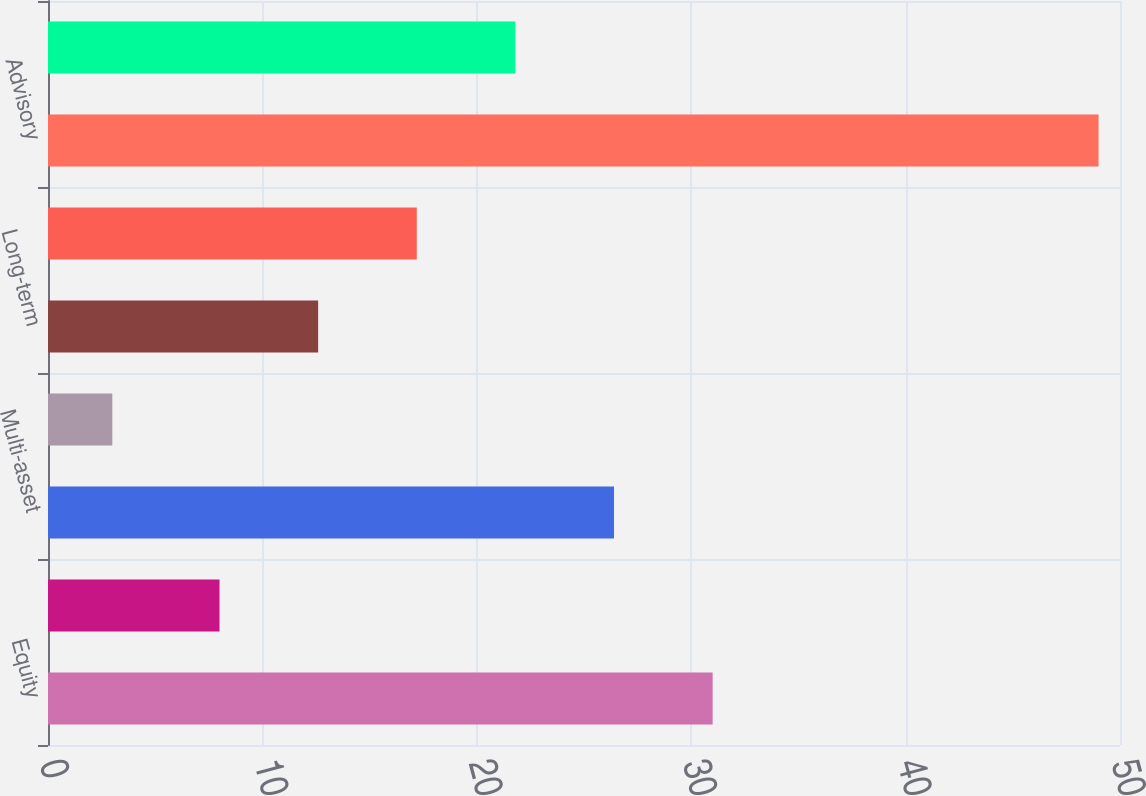Convert chart to OTSL. <chart><loc_0><loc_0><loc_500><loc_500><bar_chart><fcel>Equity<fcel>Fixed income<fcel>Multi-asset<fcel>Alternatives<fcel>Long-term<fcel>Cash management<fcel>Advisory<fcel>Total<nl><fcel>31<fcel>8<fcel>26.4<fcel>3<fcel>12.6<fcel>17.2<fcel>49<fcel>21.8<nl></chart> 